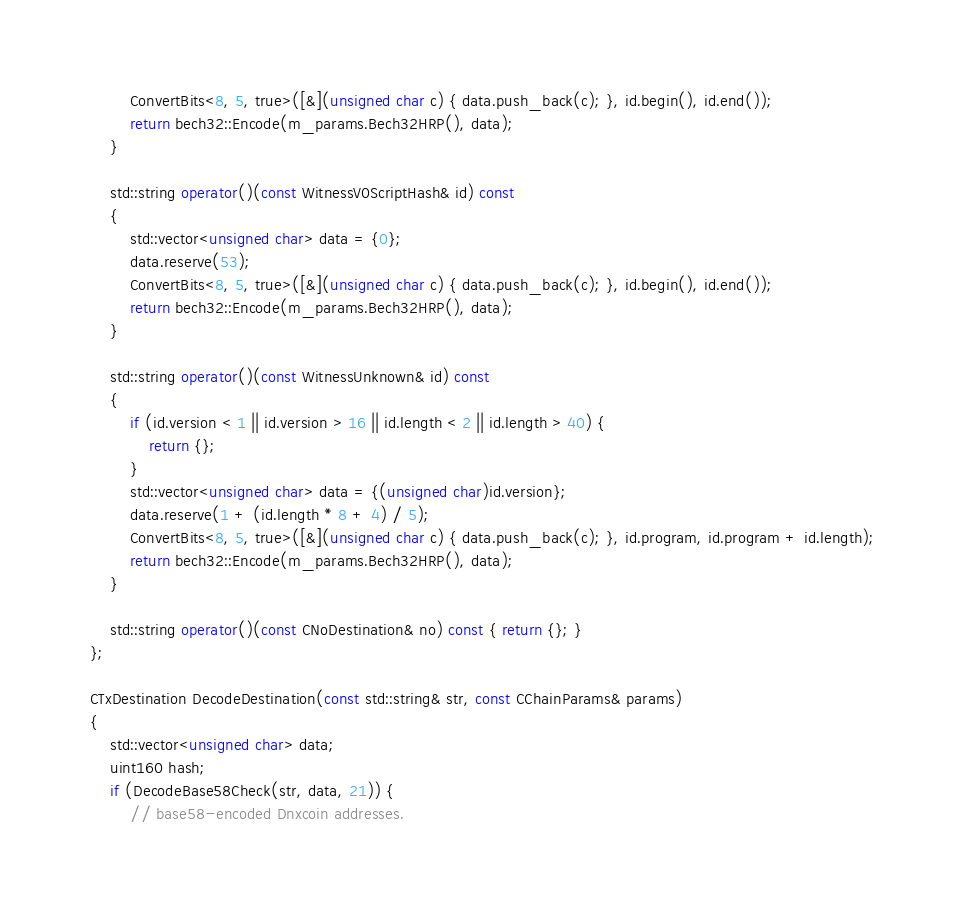<code> <loc_0><loc_0><loc_500><loc_500><_C++_>        ConvertBits<8, 5, true>([&](unsigned char c) { data.push_back(c); }, id.begin(), id.end());
        return bech32::Encode(m_params.Bech32HRP(), data);
    }

    std::string operator()(const WitnessV0ScriptHash& id) const
    {
        std::vector<unsigned char> data = {0};
        data.reserve(53);
        ConvertBits<8, 5, true>([&](unsigned char c) { data.push_back(c); }, id.begin(), id.end());
        return bech32::Encode(m_params.Bech32HRP(), data);
    }

    std::string operator()(const WitnessUnknown& id) const
    {
        if (id.version < 1 || id.version > 16 || id.length < 2 || id.length > 40) {
            return {};
        }
        std::vector<unsigned char> data = {(unsigned char)id.version};
        data.reserve(1 + (id.length * 8 + 4) / 5);
        ConvertBits<8, 5, true>([&](unsigned char c) { data.push_back(c); }, id.program, id.program + id.length);
        return bech32::Encode(m_params.Bech32HRP(), data);
    }

    std::string operator()(const CNoDestination& no) const { return {}; }
};

CTxDestination DecodeDestination(const std::string& str, const CChainParams& params)
{
    std::vector<unsigned char> data;
    uint160 hash;
    if (DecodeBase58Check(str, data, 21)) {
        // base58-encoded Dnxcoin addresses.</code> 